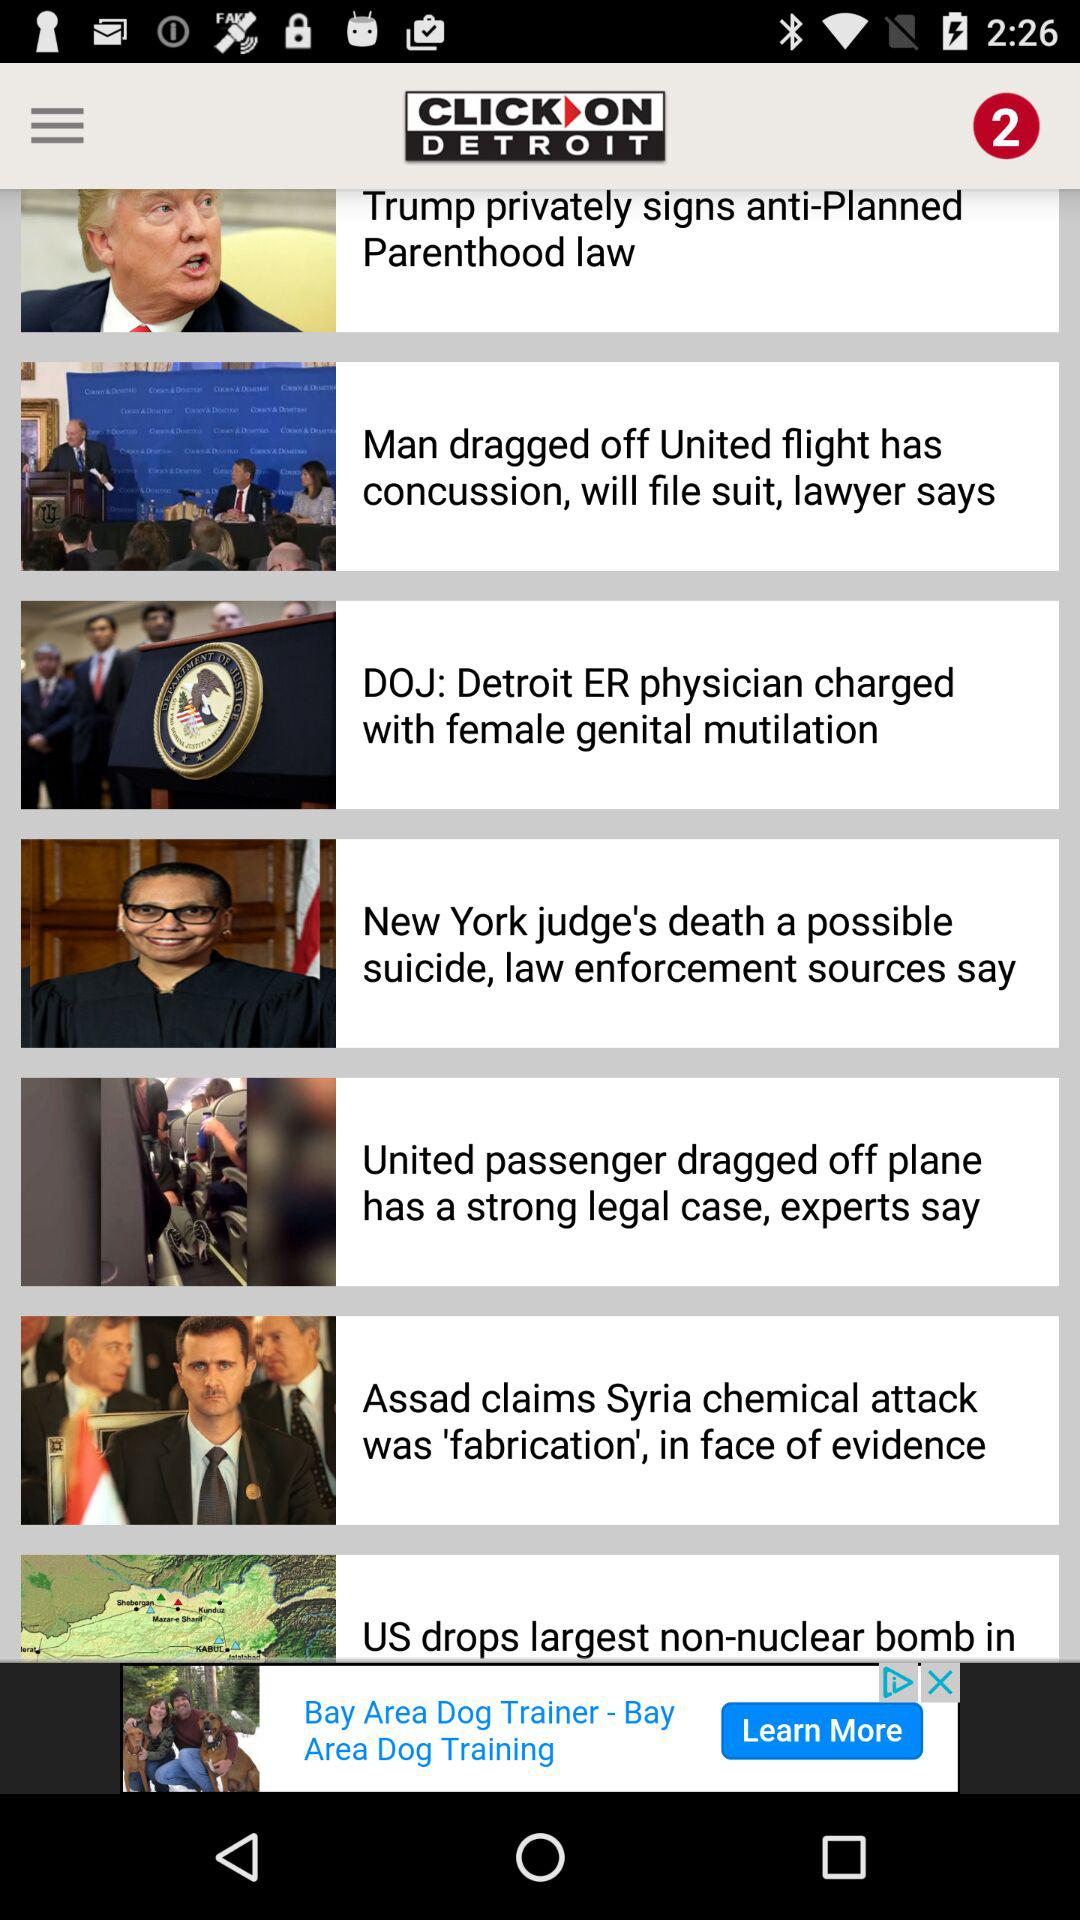What is the name of the application? The name of the application is "CLICK ON DETROIT". 